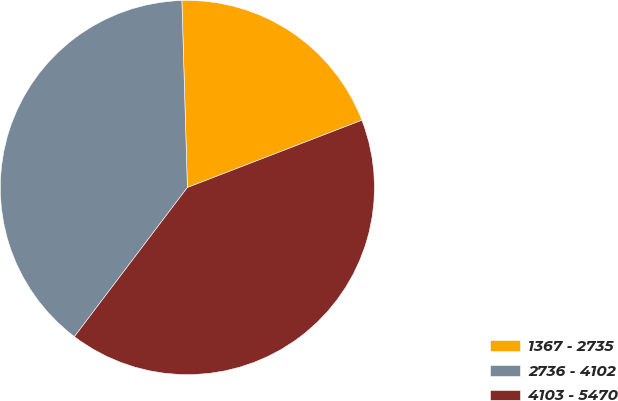Convert chart. <chart><loc_0><loc_0><loc_500><loc_500><pie_chart><fcel>1367 - 2735<fcel>2736 - 4102<fcel>4103 - 5470<nl><fcel>19.61%<fcel>39.22%<fcel>41.18%<nl></chart> 